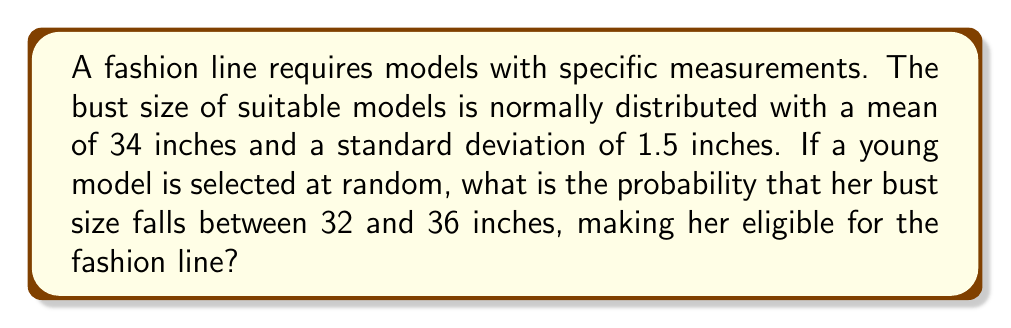Give your solution to this math problem. Let's approach this step-by-step:

1) We're dealing with a normal distribution where:
   $\mu = 34$ inches (mean)
   $\sigma = 1.5$ inches (standard deviation)

2) We need to find $P(32 \leq X \leq 36)$, where $X$ is the bust size.

3) To use the standard normal distribution, we need to standardize these values:

   For 32 inches: $z_1 = \frac{32 - 34}{1.5} = -\frac{4}{3} \approx -1.33$
   For 36 inches: $z_2 = \frac{36 - 34}{1.5} = \frac{4}{3} \approx 1.33$

4) Now we need to find $P(-1.33 \leq Z \leq 1.33)$

5) Using the standard normal distribution table or a calculator:

   $P(Z \leq 1.33) = 0.9082$
   $P(Z \leq -1.33) = 1 - 0.9082 = 0.0918$

6) The probability we're looking for is:

   $P(-1.33 \leq Z \leq 1.33) = P(Z \leq 1.33) - P(Z \leq -1.33)$
   $= 0.9082 - 0.0918 = 0.8164$

Therefore, the probability that a randomly selected model's bust size falls between 32 and 36 inches is approximately 0.8164 or 81.64%.
Answer: 0.8164 